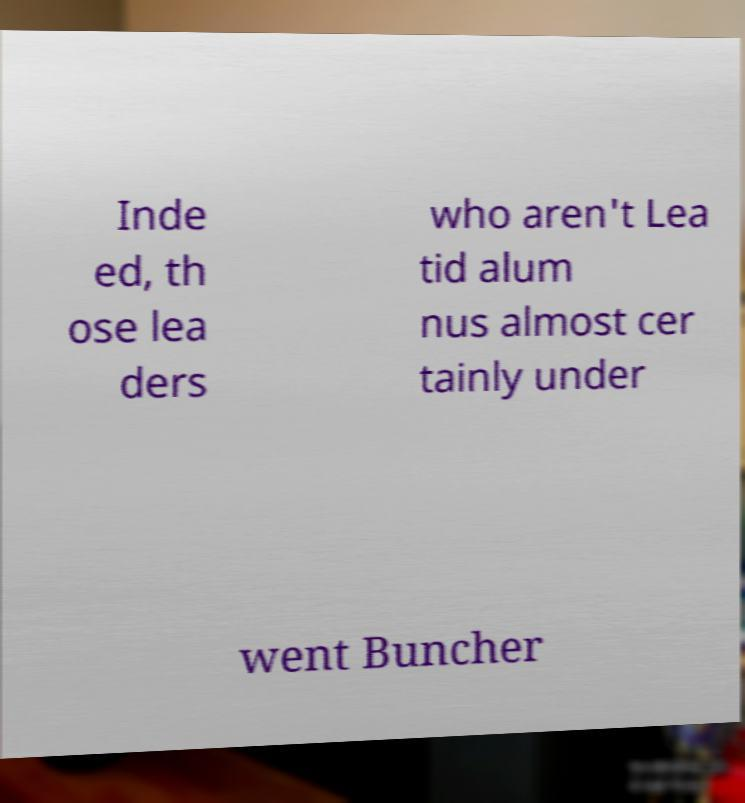For documentation purposes, I need the text within this image transcribed. Could you provide that? Inde ed, th ose lea ders who aren't Lea tid alum nus almost cer tainly under went Buncher 